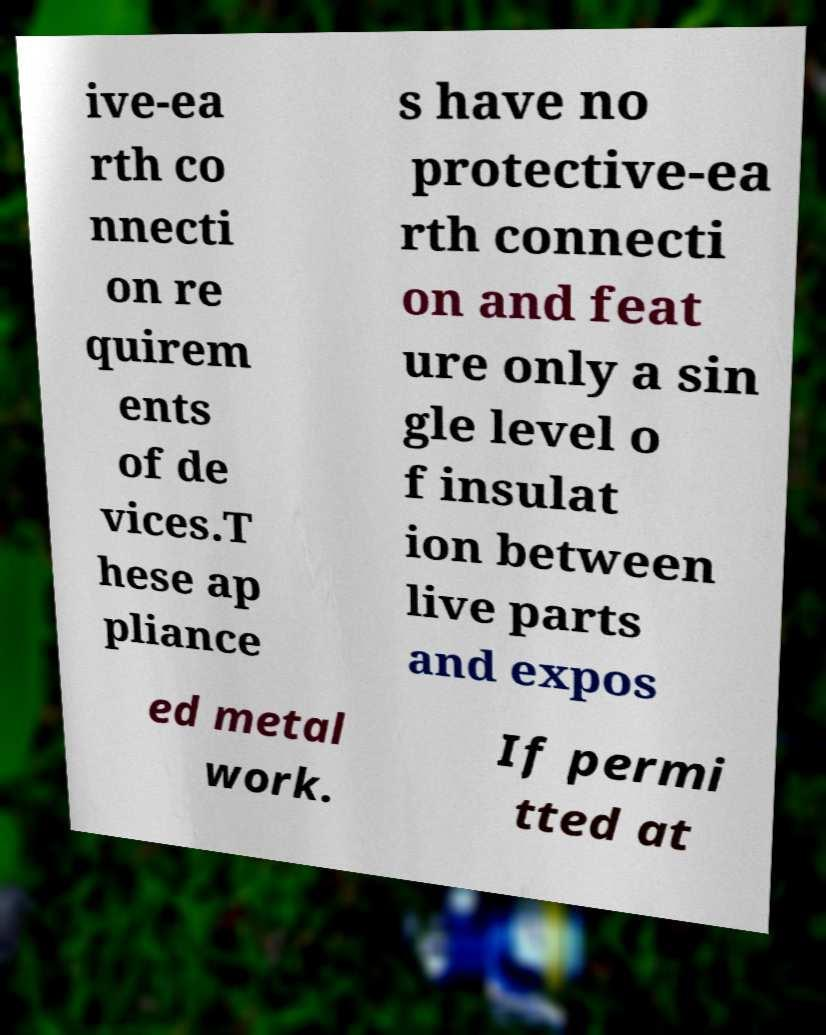I need the written content from this picture converted into text. Can you do that? ive-ea rth co nnecti on re quirem ents of de vices.T hese ap pliance s have no protective-ea rth connecti on and feat ure only a sin gle level o f insulat ion between live parts and expos ed metal work. If permi tted at 